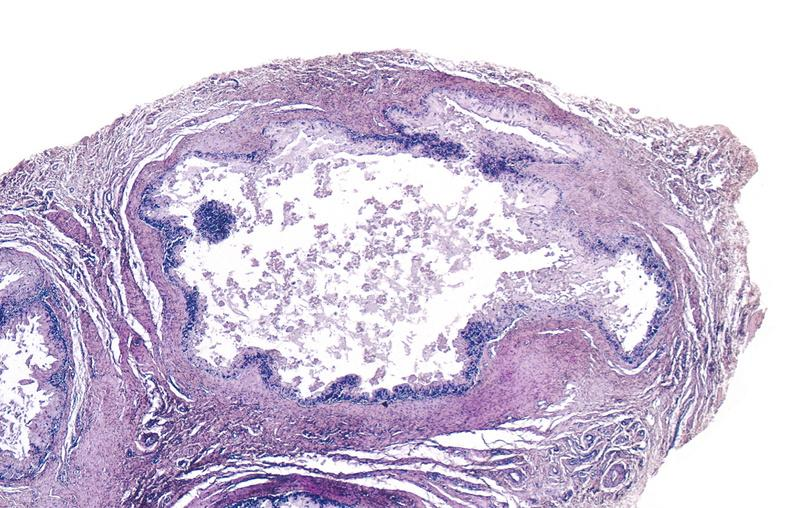what does this image show?
Answer the question using a single word or phrase. Gout 